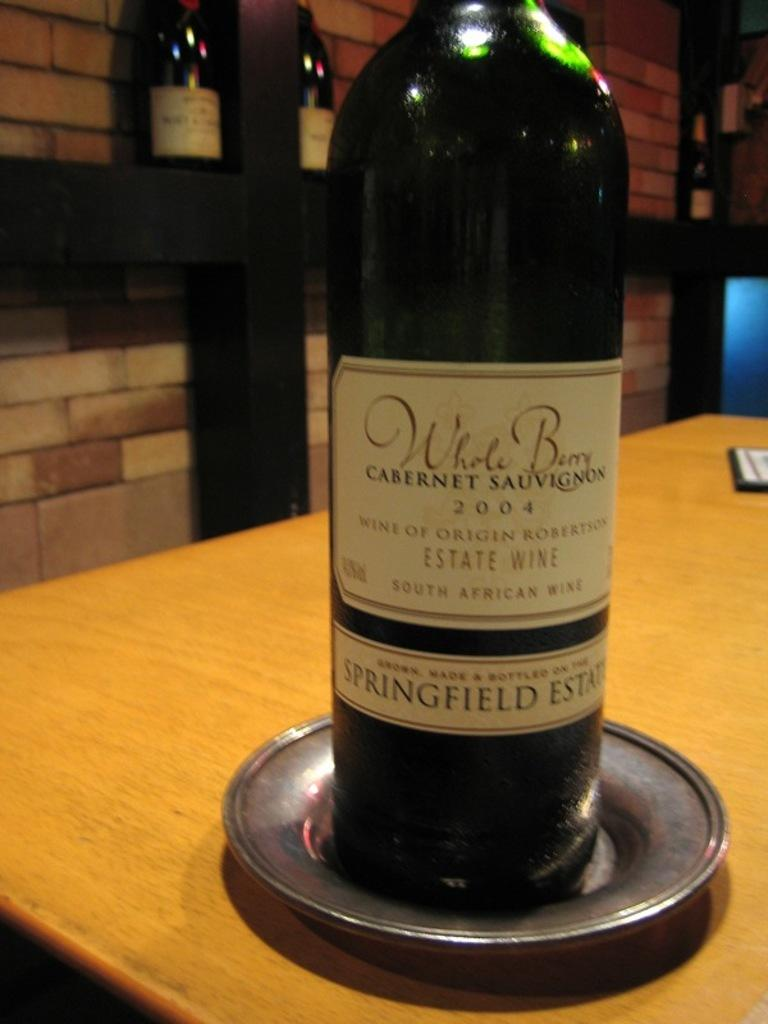Provide a one-sentence caption for the provided image. A bottle of South African wine called Whole Berry. 